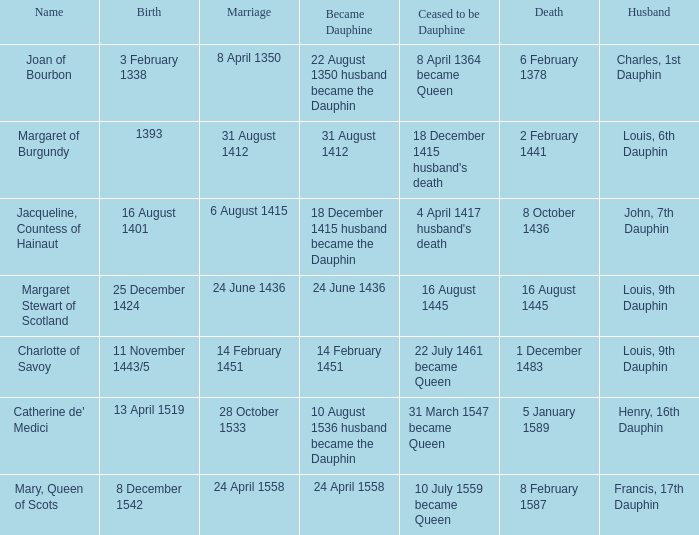What was the date of the marriage that coincided with becoming dauphine on august 31, 1412? 31 August 1412. 